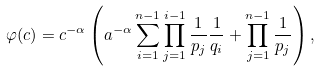<formula> <loc_0><loc_0><loc_500><loc_500>\varphi ( c ) = c ^ { - \alpha } \left ( a ^ { - \alpha } \sum _ { i = 1 } ^ { n - 1 } \prod _ { j = 1 } ^ { i - 1 } \frac { 1 } { p _ { j } } \frac { 1 } { q _ { i } } + \prod _ { j = 1 } ^ { n - 1 } \frac { 1 } { p _ { j } } \right ) ,</formula> 